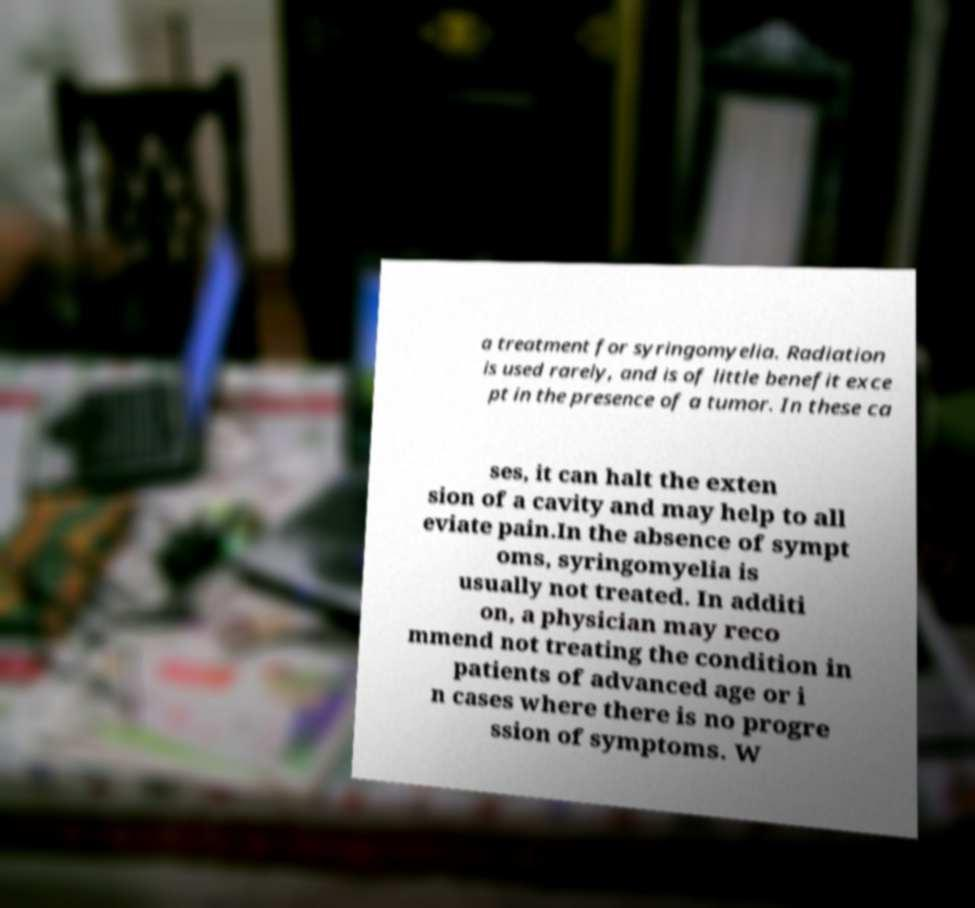I need the written content from this picture converted into text. Can you do that? a treatment for syringomyelia. Radiation is used rarely, and is of little benefit exce pt in the presence of a tumor. In these ca ses, it can halt the exten sion of a cavity and may help to all eviate pain.In the absence of sympt oms, syringomyelia is usually not treated. In additi on, a physician may reco mmend not treating the condition in patients of advanced age or i n cases where there is no progre ssion of symptoms. W 